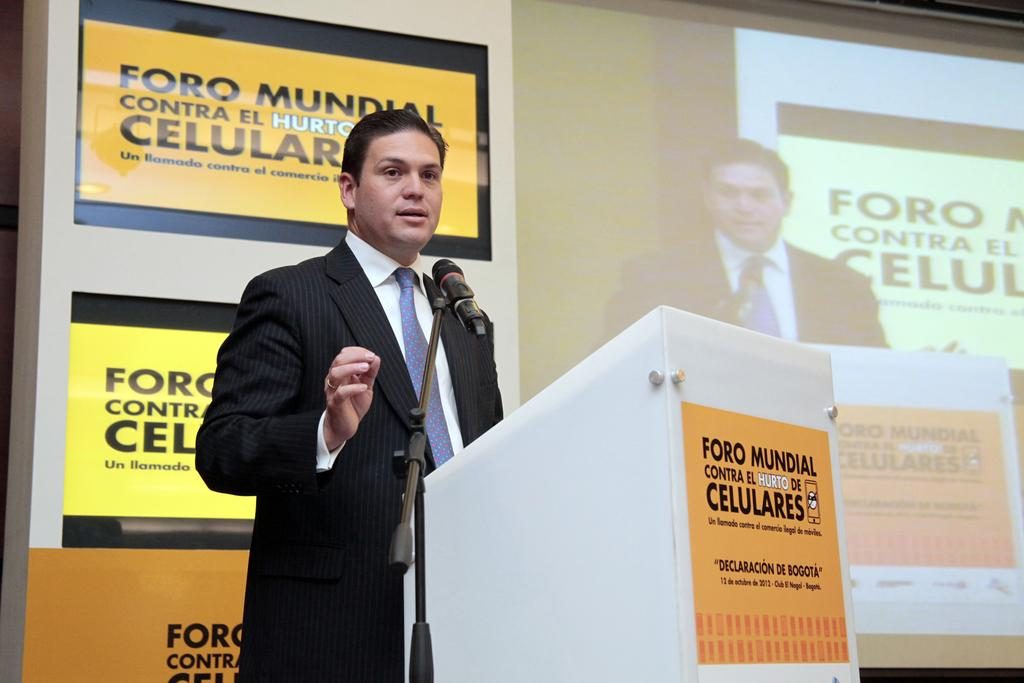Who or what is present in the image? There is a person in the image. What is the person wearing? The person is wearing clothes. Where is the person standing in relation to the podium? The person is standing in front of a podium. What is located beside the podium? The podium is beside a mic. What can be seen on the right side of the image? There is a screen on the right side of the image. What type of beam is holding up the cart in the image? There is no cart or beam present in the image. How many bottles are visible on the screen in the image? There are no bottles visible on the screen in the image. 